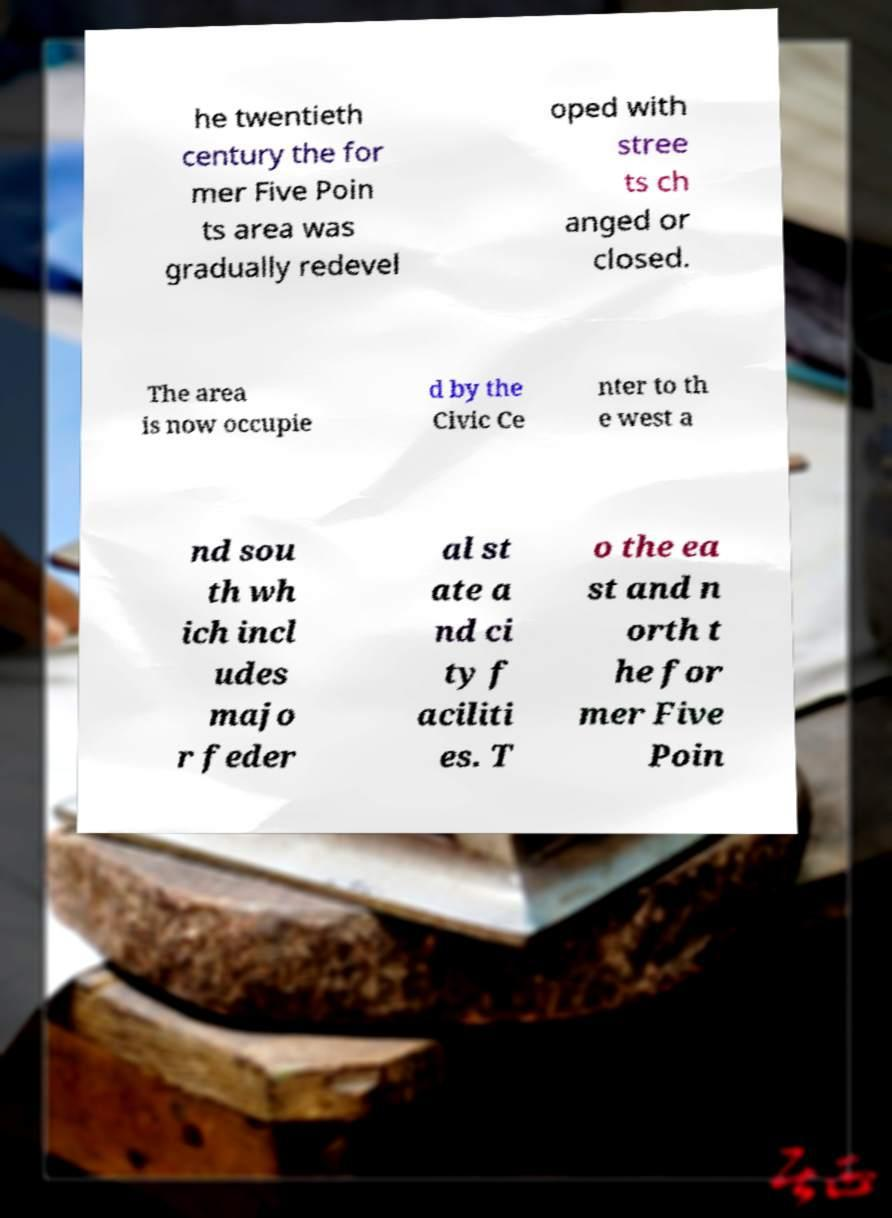I need the written content from this picture converted into text. Can you do that? he twentieth century the for mer Five Poin ts area was gradually redevel oped with stree ts ch anged or closed. The area is now occupie d by the Civic Ce nter to th e west a nd sou th wh ich incl udes majo r feder al st ate a nd ci ty f aciliti es. T o the ea st and n orth t he for mer Five Poin 